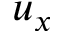Convert formula to latex. <formula><loc_0><loc_0><loc_500><loc_500>u _ { x }</formula> 